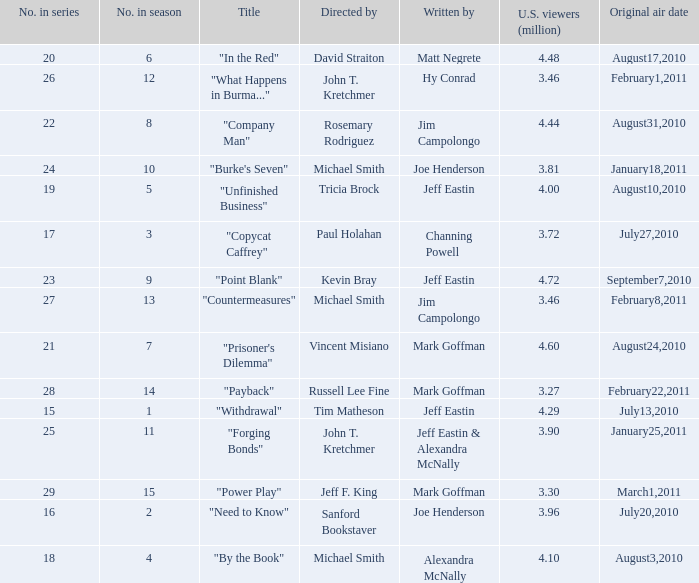How many episodes in the season had 3.81 million US viewers? 1.0. 